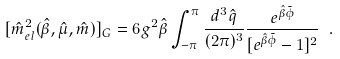<formula> <loc_0><loc_0><loc_500><loc_500>[ \hat { m } _ { e l } ^ { 2 } ( \hat { \beta } , \hat { \mu } , \hat { m } ) ] _ { G } = 6 g ^ { 2 } \hat { \beta } \int ^ { \pi } _ { - \pi } \frac { d ^ { 3 } \hat { q } } { ( 2 \pi ) ^ { 3 } } \frac { e ^ { \hat { \beta } \tilde { \phi } } } { [ e ^ { \hat { \beta } \tilde { \phi } } - 1 ] ^ { 2 } } \ .</formula> 